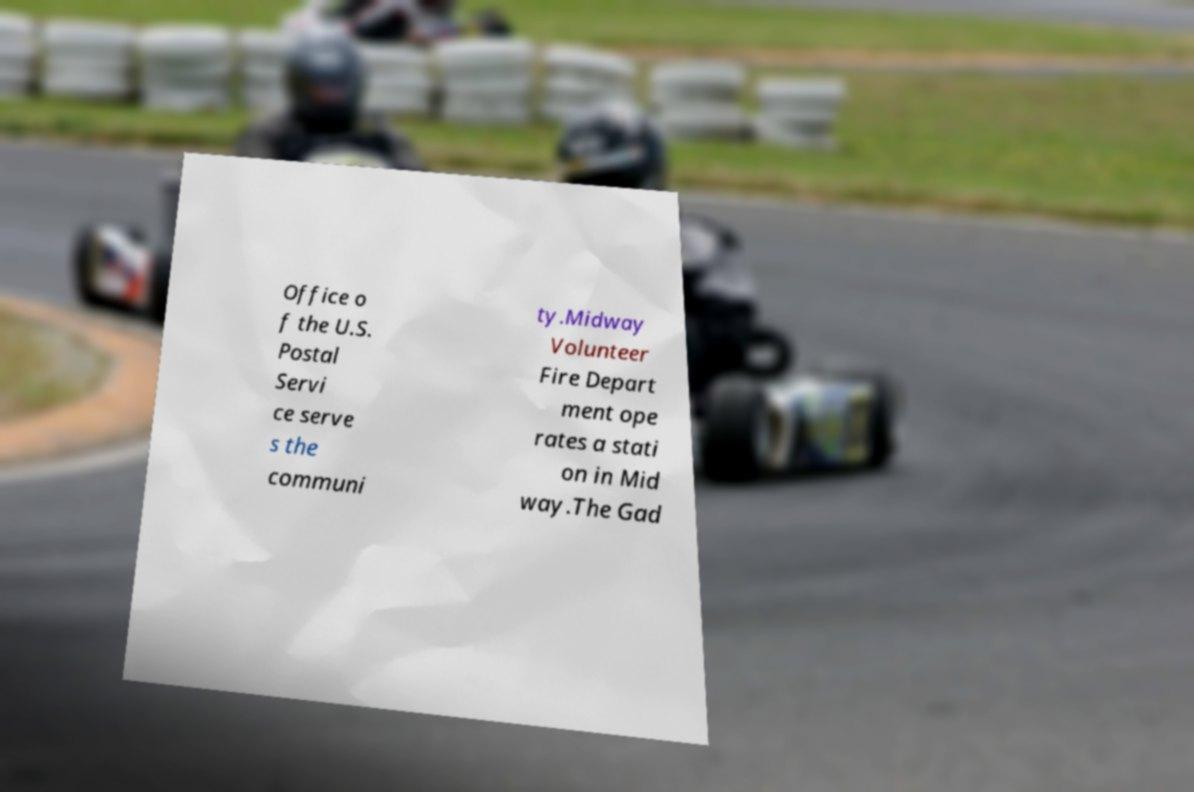Can you read and provide the text displayed in the image?This photo seems to have some interesting text. Can you extract and type it out for me? Office o f the U.S. Postal Servi ce serve s the communi ty.Midway Volunteer Fire Depart ment ope rates a stati on in Mid way.The Gad 